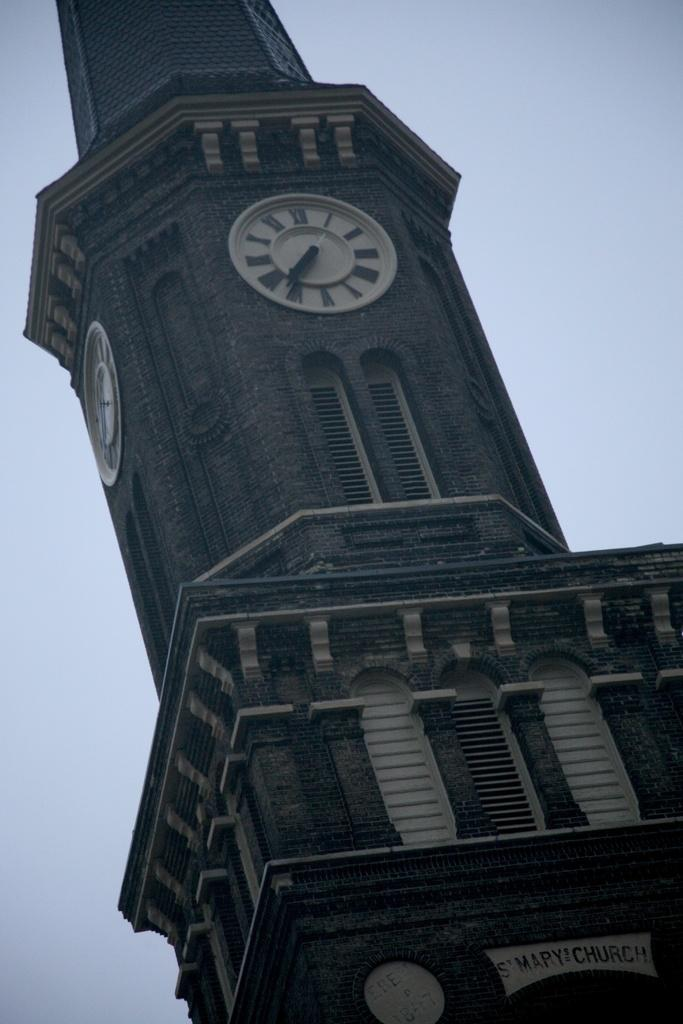What is the main structure in the image? There is a tower with clocks in the image. What are some features of the tower? The tower has walls, windows, and text on it. What can be seen in the background of the image? The sky is visible in the background of the image. What type of clouds can be seen in the image? There are no clouds mentioned in the facts provided. The image only mentions the tower and the sky visible in the background. 